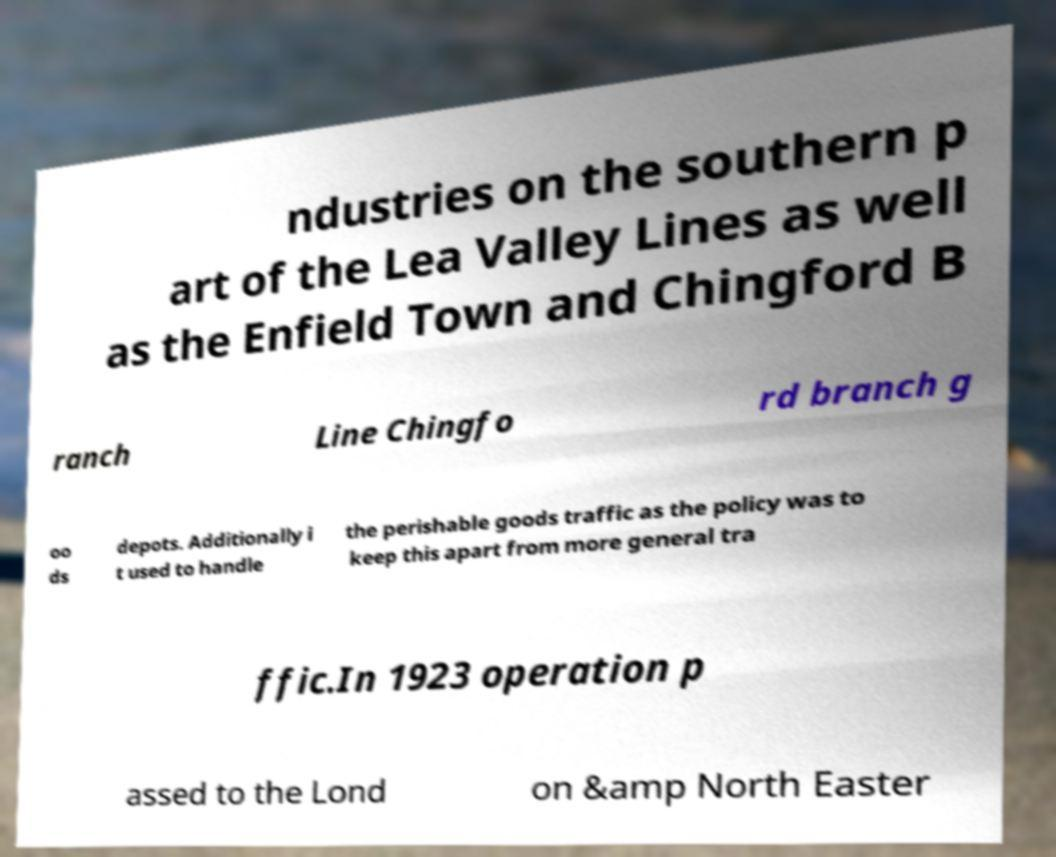What messages or text are displayed in this image? I need them in a readable, typed format. ndustries on the southern p art of the Lea Valley Lines as well as the Enfield Town and Chingford B ranch Line Chingfo rd branch g oo ds depots. Additionally i t used to handle the perishable goods traffic as the policy was to keep this apart from more general tra ffic.In 1923 operation p assed to the Lond on &amp North Easter 